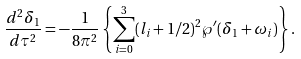Convert formula to latex. <formula><loc_0><loc_0><loc_500><loc_500>\frac { d ^ { 2 } \delta _ { 1 } } { d \tau ^ { 2 } } = - \frac { 1 } { 8 \pi ^ { 2 } } \left \{ \sum _ { i = 0 } ^ { 3 } ( l _ { i } + 1 / 2 ) ^ { 2 } \wp ^ { \prime } ( \delta _ { 1 } + \omega _ { i } ) \right \} .</formula> 